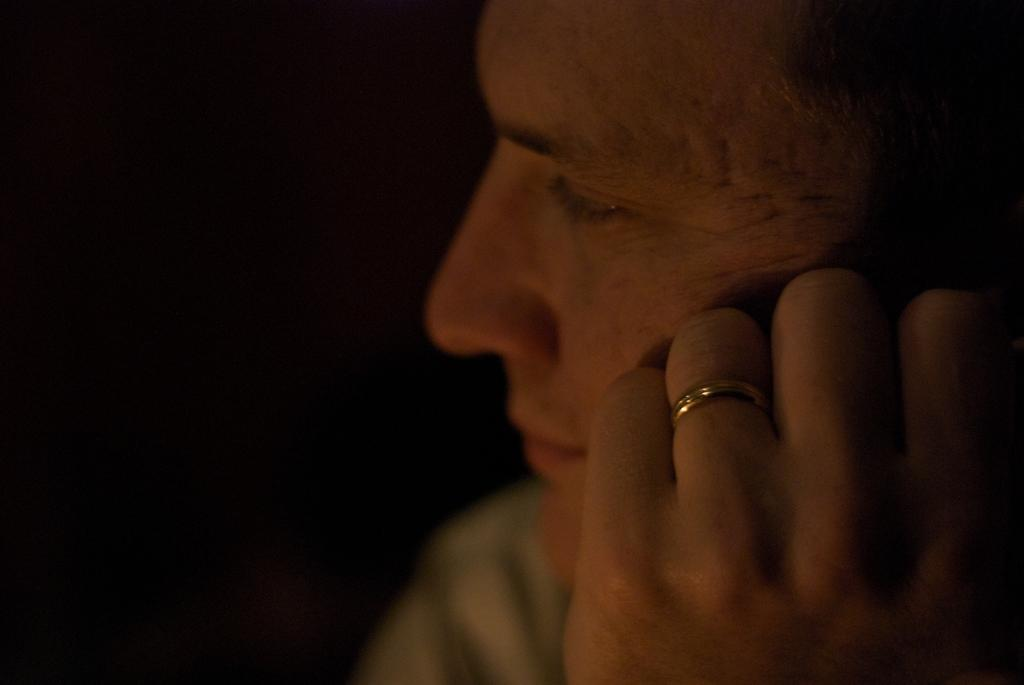What is: What is located on the right side of the image? There is a person on the right side of the image. Can you describe any specific details about the person? The person has a ring on their finger. What can be observed about the left side of the image? The left side of the image appears to be dark. What type of brake can be seen on the person's finger in the image? There is no brake present on the person's finger in the image; they are wearing a ring. What dish is being served on the plate in the image? There is no plate present in the image. 